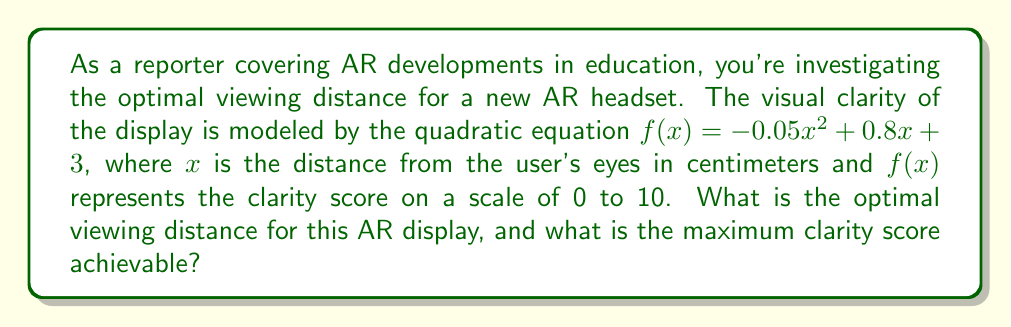Solve this math problem. To find the optimal viewing distance and maximum clarity score, we need to find the vertex of the quadratic function. The quadratic function is in the form $f(x) = ax^2 + bx + c$, where:

$a = -0.05$
$b = 0.8$
$c = 3$

The x-coordinate of the vertex represents the optimal viewing distance, and the y-coordinate represents the maximum clarity score. We can find these using the following steps:

1. Calculate the x-coordinate of the vertex using the formula: $x = -\frac{b}{2a}$

   $x = -\frac{0.8}{2(-0.05)} = -\frac{0.8}{-0.1} = 8$ cm

2. Calculate the maximum clarity score by plugging the x-value into the original function:

   $f(8) = -0.05(8)^2 + 0.8(8) + 3$
   $= -0.05(64) + 6.4 + 3$
   $= -3.2 + 6.4 + 3$
   $= 6.2$

Therefore, the optimal viewing distance is 8 cm, and the maximum clarity score achievable is 6.2.
Answer: The optimal viewing distance is 8 cm, and the maximum clarity score achievable is 6.2. 